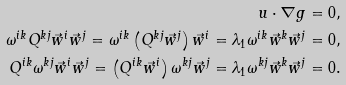<formula> <loc_0><loc_0><loc_500><loc_500>u \cdot \nabla { g } & = 0 , \\ \omega ^ { i k } Q ^ { k j } \vec { w } ^ { i } \vec { w } ^ { j } = \omega ^ { i k } \left ( Q ^ { k j } \vec { w } ^ { j } \right ) \vec { w } ^ { i } = \lambda _ { 1 } \omega ^ { i k } \vec { w } ^ { k } \vec { w } ^ { j } & = 0 , \\ Q ^ { i k } \omega ^ { k j } \vec { w } ^ { i } \vec { w } ^ { j } = \left ( Q ^ { i k } \vec { w } ^ { i } \right ) \omega ^ { k j } \vec { w } ^ { j } = \lambda _ { 1 } \omega ^ { k j } \vec { w } ^ { k } \vec { w } ^ { j } & = 0 .</formula> 